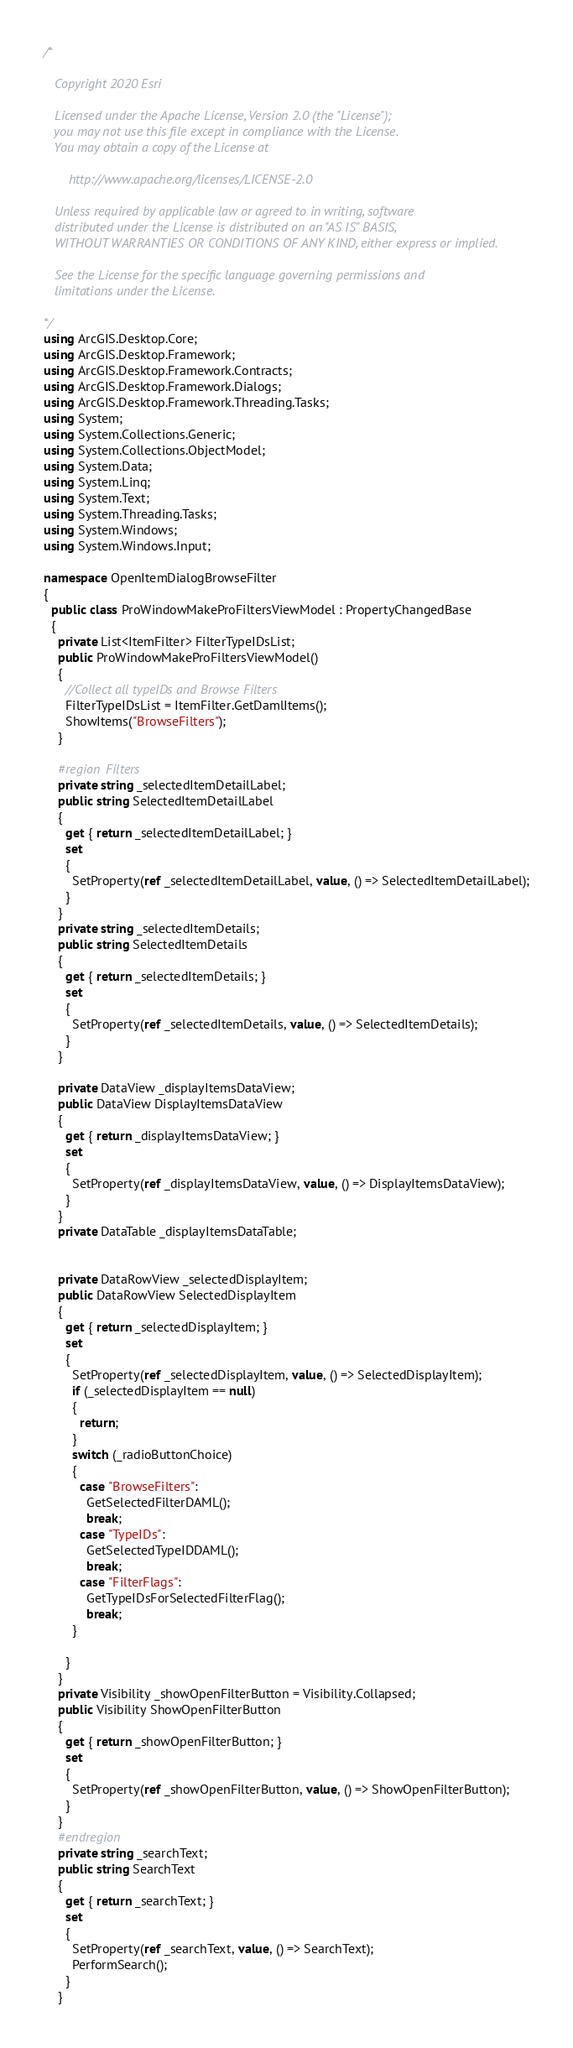<code> <loc_0><loc_0><loc_500><loc_500><_C#_>/*

   Copyright 2020 Esri

   Licensed under the Apache License, Version 2.0 (the "License");
   you may not use this file except in compliance with the License.
   You may obtain a copy of the License at

       http://www.apache.org/licenses/LICENSE-2.0

   Unless required by applicable law or agreed to in writing, software
   distributed under the License is distributed on an "AS IS" BASIS,
   WITHOUT WARRANTIES OR CONDITIONS OF ANY KIND, either express or implied.

   See the License for the specific language governing permissions and
   limitations under the License.

*/
using ArcGIS.Desktop.Core;
using ArcGIS.Desktop.Framework;
using ArcGIS.Desktop.Framework.Contracts;
using ArcGIS.Desktop.Framework.Dialogs;
using ArcGIS.Desktop.Framework.Threading.Tasks;
using System;
using System.Collections.Generic;
using System.Collections.ObjectModel;
using System.Data;
using System.Linq;
using System.Text;
using System.Threading.Tasks;
using System.Windows;
using System.Windows.Input;

namespace OpenItemDialogBrowseFilter
{
  public class ProWindowMakeProFiltersViewModel : PropertyChangedBase
  {
    private List<ItemFilter> FilterTypeIDsList;
    public ProWindowMakeProFiltersViewModel()
    {
      //Collect all typeIDs and Browse Filters 
      FilterTypeIDsList = ItemFilter.GetDamlItems();
      ShowItems("BrowseFilters");
    }

    #region Filters
    private string _selectedItemDetailLabel;
    public string SelectedItemDetailLabel
    {
      get { return _selectedItemDetailLabel; }
      set
      {
        SetProperty(ref _selectedItemDetailLabel, value, () => SelectedItemDetailLabel);
      }
    }
    private string _selectedItemDetails;
    public string SelectedItemDetails
    {
      get { return _selectedItemDetails; }
      set
      {
        SetProperty(ref _selectedItemDetails, value, () => SelectedItemDetails);
      }
    }

    private DataView _displayItemsDataView;
    public DataView DisplayItemsDataView
    {
      get { return _displayItemsDataView; }
      set
      {
        SetProperty(ref _displayItemsDataView, value, () => DisplayItemsDataView);
      }
    }
    private DataTable _displayItemsDataTable;


    private DataRowView _selectedDisplayItem;
    public DataRowView SelectedDisplayItem
    {
      get { return _selectedDisplayItem; }
      set
      {
        SetProperty(ref _selectedDisplayItem, value, () => SelectedDisplayItem);
        if (_selectedDisplayItem == null)
        {
          return;
        }
        switch (_radioButtonChoice)
        {
          case "BrowseFilters":
            GetSelectedFilterDAML();
            break;
          case "TypeIDs":
            GetSelectedTypeIDDAML();
            break;
          case "FilterFlags":
            GetTypeIDsForSelectedFilterFlag();
            break;
        }

      }
    }
    private Visibility _showOpenFilterButton = Visibility.Collapsed;
    public Visibility ShowOpenFilterButton
    {
      get { return _showOpenFilterButton; }
      set
      {
        SetProperty(ref _showOpenFilterButton, value, () => ShowOpenFilterButton);
      }
    }
    #endregion
    private string _searchText;
    public string SearchText
    {
      get { return _searchText; }
      set
      {
        SetProperty(ref _searchText, value, () => SearchText);
        PerformSearch();
      }
    }</code> 